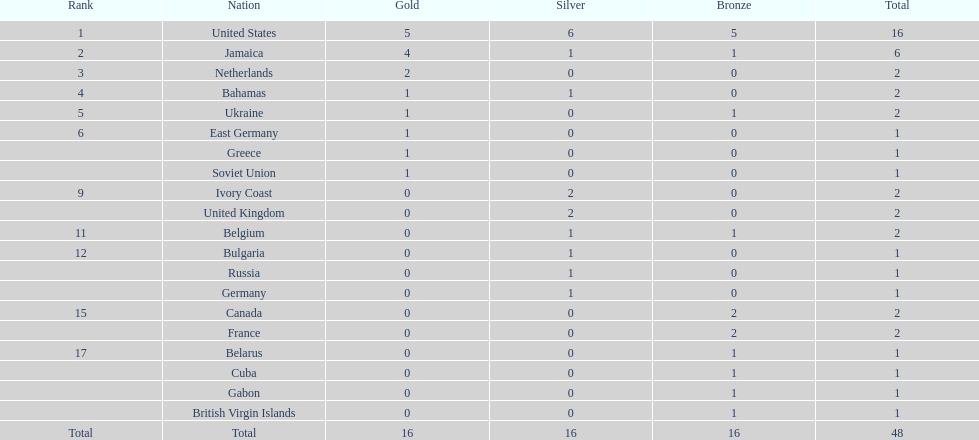How many national teams obtained more than one silver medal? 3. 